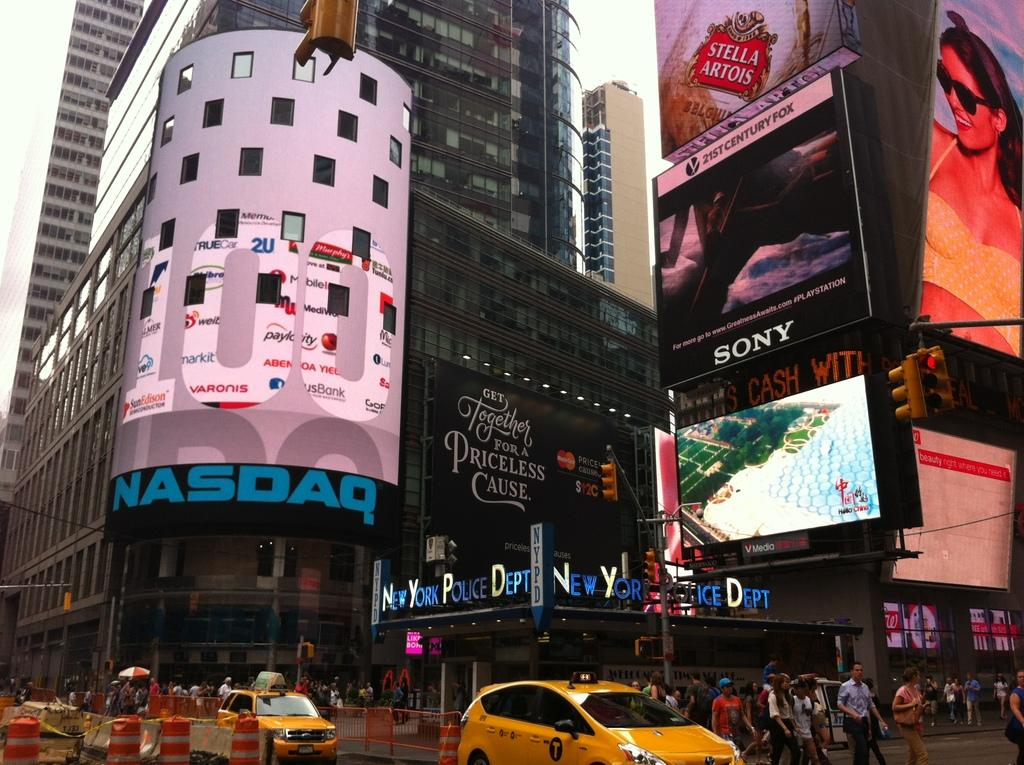<image>
Create a compact narrative representing the image presented. the corner ad is for the nasdaq and is very large 